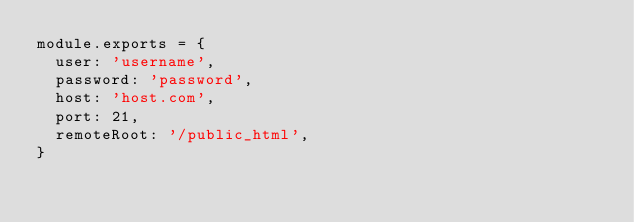Convert code to text. <code><loc_0><loc_0><loc_500><loc_500><_JavaScript_>module.exports = {
	user: 'username',
	password: 'password',
	host: 'host.com',
	port: 21,
	remoteRoot: '/public_html',
}
</code> 